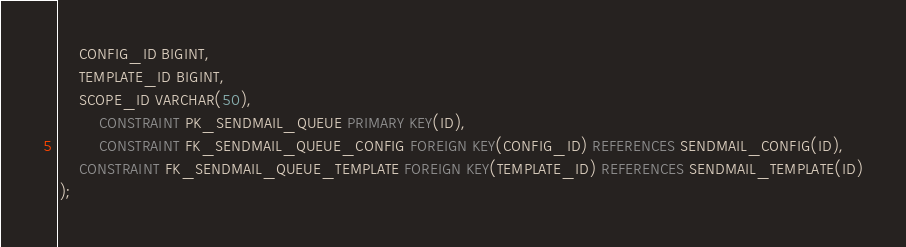Convert code to text. <code><loc_0><loc_0><loc_500><loc_500><_SQL_>	CONFIG_ID BIGINT,
	TEMPLATE_ID BIGINT,
	SCOPE_ID VARCHAR(50),
        CONSTRAINT PK_SENDMAIL_QUEUE PRIMARY KEY(ID),
        CONSTRAINT FK_SENDMAIL_QUEUE_CONFIG FOREIGN KEY(CONFIG_ID) REFERENCES SENDMAIL_CONFIG(ID),
	CONSTRAINT FK_SENDMAIL_QUEUE_TEMPLATE FOREIGN KEY(TEMPLATE_ID) REFERENCES SENDMAIL_TEMPLATE(ID)
);

</code> 